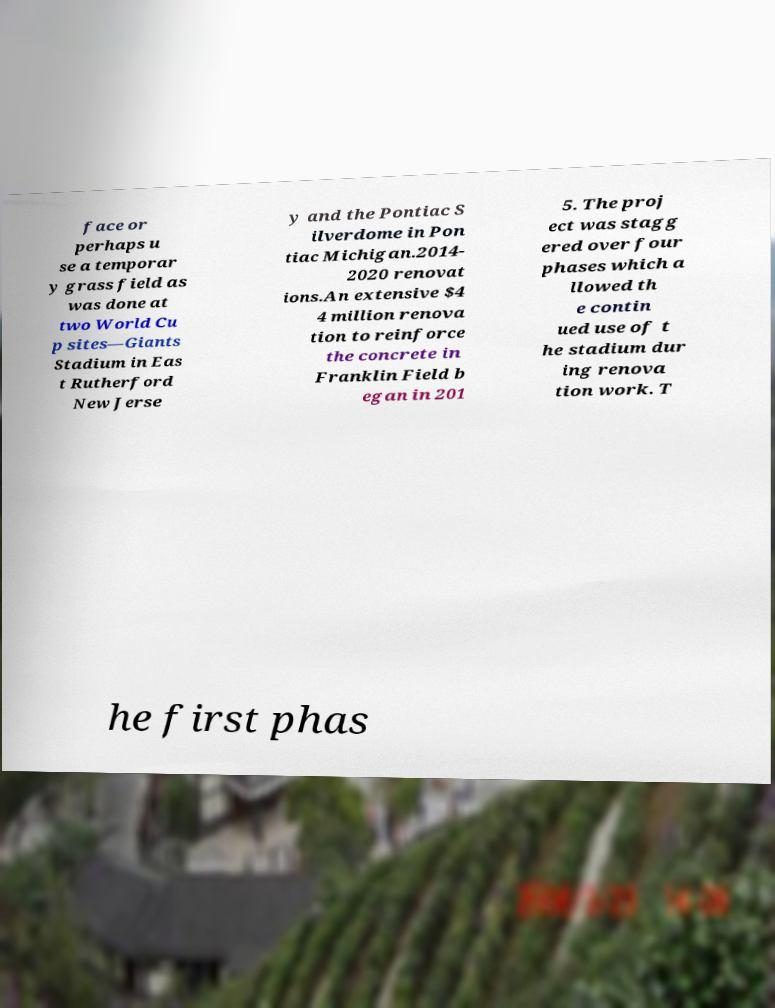What messages or text are displayed in this image? I need them in a readable, typed format. face or perhaps u se a temporar y grass field as was done at two World Cu p sites—Giants Stadium in Eas t Rutherford New Jerse y and the Pontiac S ilverdome in Pon tiac Michigan.2014- 2020 renovat ions.An extensive $4 4 million renova tion to reinforce the concrete in Franklin Field b egan in 201 5. The proj ect was stagg ered over four phases which a llowed th e contin ued use of t he stadium dur ing renova tion work. T he first phas 